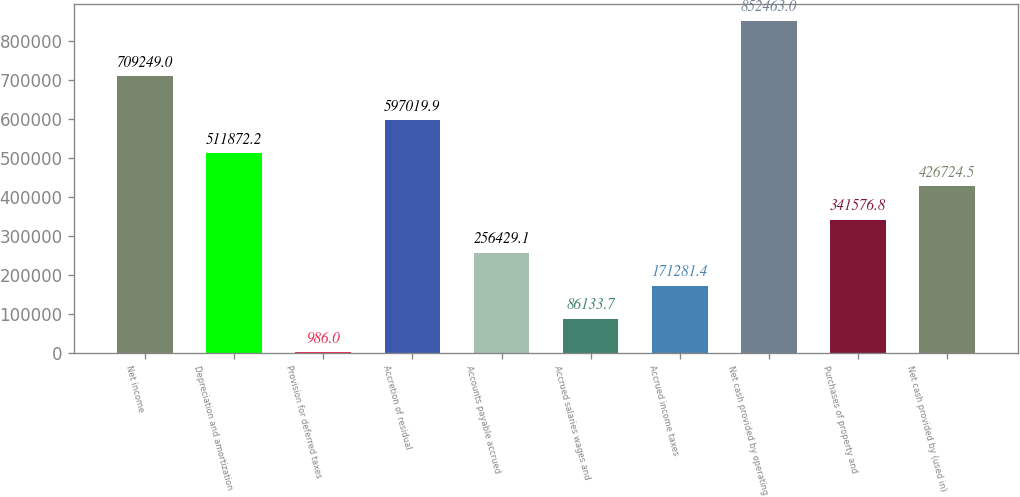<chart> <loc_0><loc_0><loc_500><loc_500><bar_chart><fcel>Net income<fcel>Depreciation and amortization<fcel>Provision for deferred taxes<fcel>Accretion of residual<fcel>Accounts payable accrued<fcel>Accrued salaries wages and<fcel>Accrued income taxes<fcel>Net cash provided by operating<fcel>Purchases of property and<fcel>Net cash provided by (used in)<nl><fcel>709249<fcel>511872<fcel>986<fcel>597020<fcel>256429<fcel>86133.7<fcel>171281<fcel>852463<fcel>341577<fcel>426724<nl></chart> 